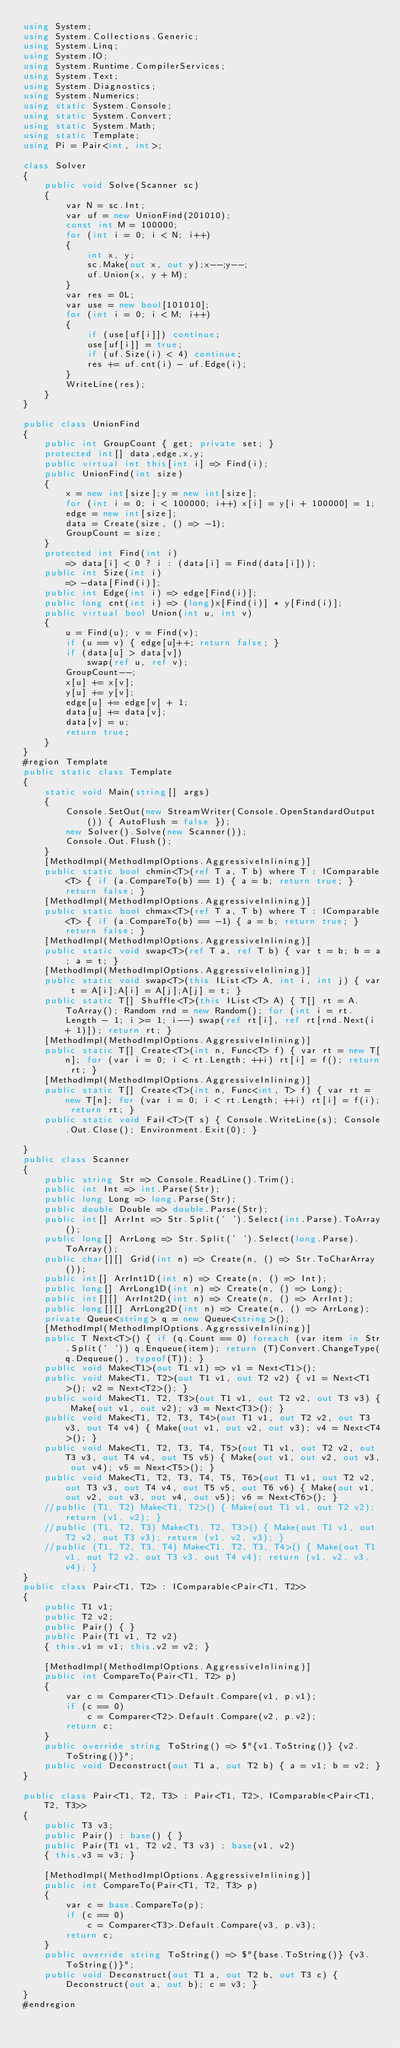Convert code to text. <code><loc_0><loc_0><loc_500><loc_500><_C#_>using System;
using System.Collections.Generic;
using System.Linq;
using System.IO;
using System.Runtime.CompilerServices;
using System.Text;
using System.Diagnostics;
using System.Numerics;
using static System.Console;
using static System.Convert;
using static System.Math;
using static Template;
using Pi = Pair<int, int>;

class Solver
{
    public void Solve(Scanner sc)
    {
        var N = sc.Int;
        var uf = new UnionFind(201010);
        const int M = 100000;
        for (int i = 0; i < N; i++)
        {
            int x, y;
            sc.Make(out x, out y);x--;y--;
            uf.Union(x, y + M);
        }
        var res = 0L;
        var use = new bool[101010];
        for (int i = 0; i < M; i++)
        {
            if (use[uf[i]]) continue;
            use[uf[i]] = true;
            if (uf.Size(i) < 4) continue;
            res += uf.cnt(i) - uf.Edge(i);
        }
        WriteLine(res);
    }
}

public class UnionFind
{
    public int GroupCount { get; private set; }
    protected int[] data,edge,x,y;
    public virtual int this[int i] => Find(i);
    public UnionFind(int size)
    {
        x = new int[size];y = new int[size];
        for (int i = 0; i < 100000; i++) x[i] = y[i + 100000] = 1;
        edge = new int[size];
        data = Create(size, () => -1);
        GroupCount = size;
    }
    protected int Find(int i)
        => data[i] < 0 ? i : (data[i] = Find(data[i]));
    public int Size(int i)
        => -data[Find(i)];
    public int Edge(int i) => edge[Find(i)];
    public long cnt(int i) => (long)x[Find(i)] * y[Find(i)];
    public virtual bool Union(int u, int v)
    {
        u = Find(u); v = Find(v);
        if (u == v) { edge[u]++; return false; }
        if (data[u] > data[v])
            swap(ref u, ref v);
        GroupCount--;
        x[u] += x[v];
        y[u] += y[v];
        edge[u] += edge[v] + 1;
        data[u] += data[v];
        data[v] = u;
        return true;
    }
}
#region Template
public static class Template
{
    static void Main(string[] args)
    {
        Console.SetOut(new StreamWriter(Console.OpenStandardOutput()) { AutoFlush = false });
        new Solver().Solve(new Scanner());
        Console.Out.Flush();
    }
    [MethodImpl(MethodImplOptions.AggressiveInlining)]
    public static bool chmin<T>(ref T a, T b) where T : IComparable<T> { if (a.CompareTo(b) == 1) { a = b; return true; } return false; }
    [MethodImpl(MethodImplOptions.AggressiveInlining)]
    public static bool chmax<T>(ref T a, T b) where T : IComparable<T> { if (a.CompareTo(b) == -1) { a = b; return true; } return false; }
    [MethodImpl(MethodImplOptions.AggressiveInlining)]
    public static void swap<T>(ref T a, ref T b) { var t = b; b = a; a = t; }
    [MethodImpl(MethodImplOptions.AggressiveInlining)]
    public static void swap<T>(this IList<T> A, int i, int j) { var t = A[i];A[i] = A[j];A[j] = t; }
    public static T[] Shuffle<T>(this IList<T> A) { T[] rt = A.ToArray(); Random rnd = new Random(); for (int i = rt.Length - 1; i >= 1; i--) swap(ref rt[i], ref rt[rnd.Next(i + 1)]); return rt; }
    [MethodImpl(MethodImplOptions.AggressiveInlining)]
    public static T[] Create<T>(int n, Func<T> f) { var rt = new T[n]; for (var i = 0; i < rt.Length; ++i) rt[i] = f(); return rt; }
    [MethodImpl(MethodImplOptions.AggressiveInlining)]
    public static T[] Create<T>(int n, Func<int, T> f) { var rt = new T[n]; for (var i = 0; i < rt.Length; ++i) rt[i] = f(i); return rt; }
    public static void Fail<T>(T s) { Console.WriteLine(s); Console.Out.Close(); Environment.Exit(0); }

}
public class Scanner
{
    public string Str => Console.ReadLine().Trim();
    public int Int => int.Parse(Str);
    public long Long => long.Parse(Str);
    public double Double => double.Parse(Str);
    public int[] ArrInt => Str.Split(' ').Select(int.Parse).ToArray();
    public long[] ArrLong => Str.Split(' ').Select(long.Parse).ToArray();
    public char[][] Grid(int n) => Create(n, () => Str.ToCharArray());
    public int[] ArrInt1D(int n) => Create(n, () => Int);
    public long[] ArrLong1D(int n) => Create(n, () => Long);
    public int[][] ArrInt2D(int n) => Create(n, () => ArrInt);
    public long[][] ArrLong2D(int n) => Create(n, () => ArrLong);
    private Queue<string> q = new Queue<string>();
    [MethodImpl(MethodImplOptions.AggressiveInlining)]
    public T Next<T>() { if (q.Count == 0) foreach (var item in Str.Split(' ')) q.Enqueue(item); return (T)Convert.ChangeType(q.Dequeue(), typeof(T)); }
    public void Make<T1>(out T1 v1) => v1 = Next<T1>();
    public void Make<T1, T2>(out T1 v1, out T2 v2) { v1 = Next<T1>(); v2 = Next<T2>(); }
    public void Make<T1, T2, T3>(out T1 v1, out T2 v2, out T3 v3) { Make(out v1, out v2); v3 = Next<T3>(); }
    public void Make<T1, T2, T3, T4>(out T1 v1, out T2 v2, out T3 v3, out T4 v4) { Make(out v1, out v2, out v3); v4 = Next<T4>(); }
    public void Make<T1, T2, T3, T4, T5>(out T1 v1, out T2 v2, out T3 v3, out T4 v4, out T5 v5) { Make(out v1, out v2, out v3, out v4); v5 = Next<T5>(); }
    public void Make<T1, T2, T3, T4, T5, T6>(out T1 v1, out T2 v2, out T3 v3, out T4 v4, out T5 v5, out T6 v6) { Make(out v1, out v2, out v3, out v4, out v5); v6 = Next<T6>(); }
    //public (T1, T2) Make<T1, T2>() { Make(out T1 v1, out T2 v2); return (v1, v2); }
    //public (T1, T2, T3) Make<T1, T2, T3>() { Make(out T1 v1, out T2 v2, out T3 v3); return (v1, v2, v3); }
    //public (T1, T2, T3, T4) Make<T1, T2, T3, T4>() { Make(out T1 v1, out T2 v2, out T3 v3, out T4 v4); return (v1, v2, v3, v4); }
}
public class Pair<T1, T2> : IComparable<Pair<T1, T2>>
{
    public T1 v1;
    public T2 v2;
    public Pair() { }
    public Pair(T1 v1, T2 v2)
    { this.v1 = v1; this.v2 = v2; }

    [MethodImpl(MethodImplOptions.AggressiveInlining)]
    public int CompareTo(Pair<T1, T2> p)
    {
        var c = Comparer<T1>.Default.Compare(v1, p.v1);
        if (c == 0)
            c = Comparer<T2>.Default.Compare(v2, p.v2);
        return c;
    }
    public override string ToString() => $"{v1.ToString()} {v2.ToString()}";
    public void Deconstruct(out T1 a, out T2 b) { a = v1; b = v2; }
}

public class Pair<T1, T2, T3> : Pair<T1, T2>, IComparable<Pair<T1, T2, T3>>
{
    public T3 v3;
    public Pair() : base() { }
    public Pair(T1 v1, T2 v2, T3 v3) : base(v1, v2)
    { this.v3 = v3; }

    [MethodImpl(MethodImplOptions.AggressiveInlining)]
    public int CompareTo(Pair<T1, T2, T3> p)
    {
        var c = base.CompareTo(p);
        if (c == 0)
            c = Comparer<T3>.Default.Compare(v3, p.v3);
        return c;
    }
    public override string ToString() => $"{base.ToString()} {v3.ToString()}";
    public void Deconstruct(out T1 a, out T2 b, out T3 c) { Deconstruct(out a, out b); c = v3; }
}
#endregion</code> 